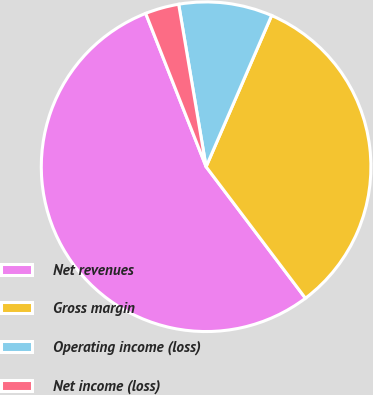Convert chart. <chart><loc_0><loc_0><loc_500><loc_500><pie_chart><fcel>Net revenues<fcel>Gross margin<fcel>Operating income (loss)<fcel>Net income (loss)<nl><fcel>54.33%<fcel>33.2%<fcel>9.17%<fcel>3.31%<nl></chart> 